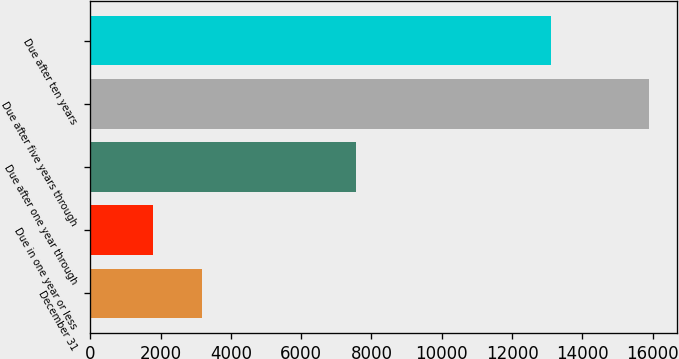Convert chart. <chart><loc_0><loc_0><loc_500><loc_500><bar_chart><fcel>December 31<fcel>Due in one year or less<fcel>Due after one year through<fcel>Due after five years through<fcel>Due after ten years<nl><fcel>3190.3<fcel>1779<fcel>7566<fcel>15892<fcel>13112<nl></chart> 